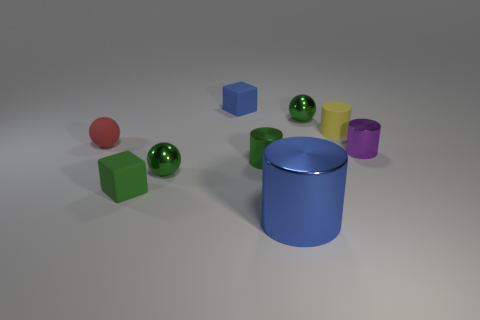What number of other objects are the same color as the large metal cylinder?
Provide a succinct answer. 1. There is a matte sphere; is its color the same as the tiny cube in front of the blue matte thing?
Your response must be concise. No. How many cyan objects are either large shiny cylinders or tiny rubber balls?
Your answer should be very brief. 0. Are there the same number of blue metallic cylinders that are behind the large blue metallic cylinder and big yellow things?
Your response must be concise. Yes. Is there any other thing that is the same size as the blue block?
Your answer should be compact. Yes. There is another rubber object that is the same shape as the big thing; what is its color?
Give a very brief answer. Yellow. How many small blue objects are the same shape as the green matte object?
Your answer should be compact. 1. There is another object that is the same color as the big metal object; what is it made of?
Your answer should be very brief. Rubber. What number of cyan rubber cubes are there?
Your answer should be very brief. 0. Are there any big things that have the same material as the large cylinder?
Provide a succinct answer. No. 